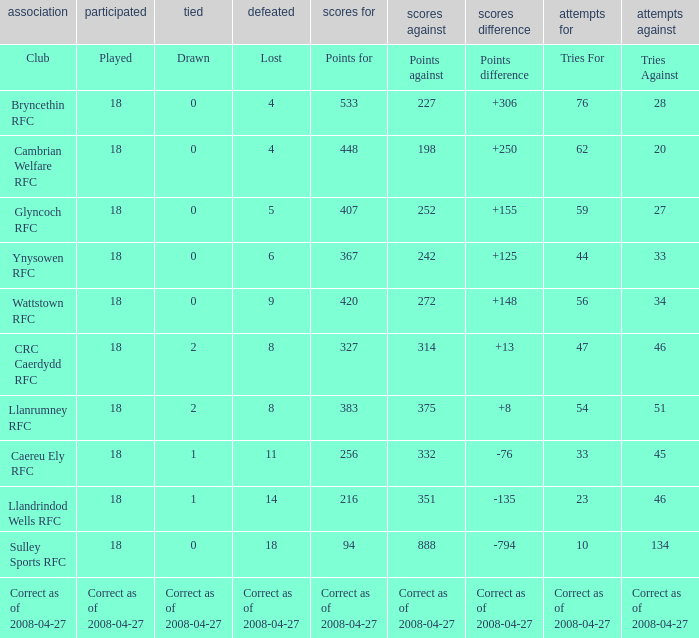What is the value for the item "Tries" when the value of the item "Played" is 18 and the value of the item "Points" is 375? 54.0. 